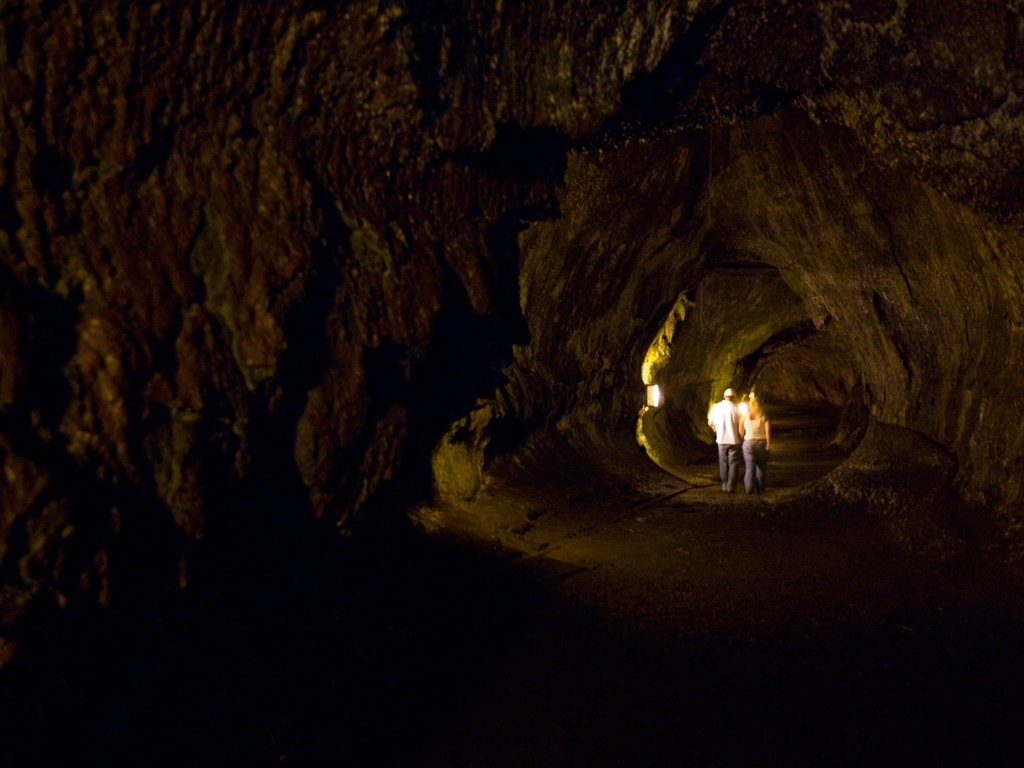Do you think this place is accessible to the public? While the image alone doesn't provide any signage or clear indicators of public access, the presence of people and what appear to be pathways or tracks on the floor suggest that it might be a location that is, at least partially, accessible to visitors. It is possible that this could be a protected area with restricted access, perhaps part of a tour under the guidance of a park ranger or a similar authority. 